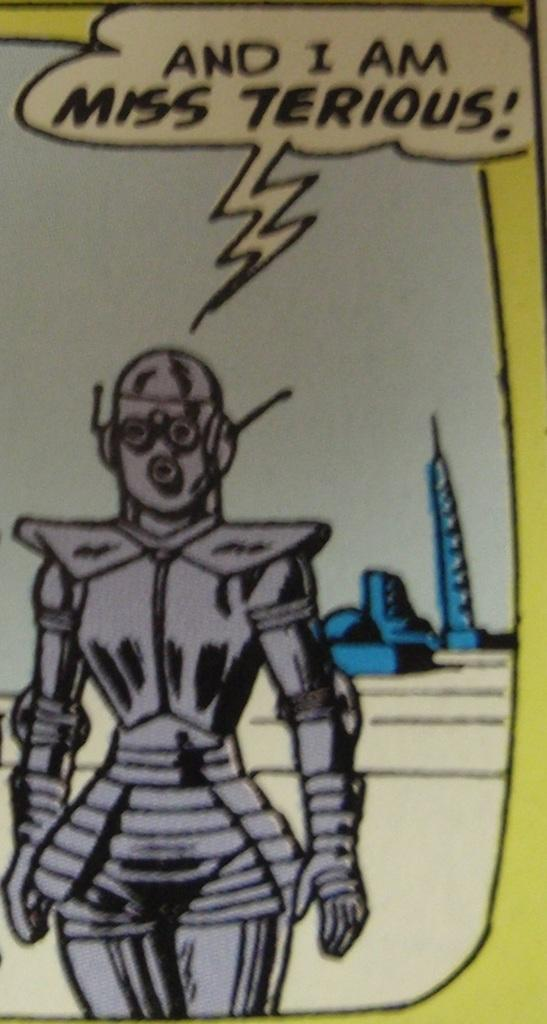What type of picture is shown in the image? The image is an animated picture. What is the main subject of the animated picture? The picture depicts a robot in the shape of a woman. What can be seen in the background of the image? The sky is visible at the top of the image. What type of yarn is the robot using to grip objects in the image? There is no yarn or gripping of objects shown in the image; it depicts an animated robot in the shape of a woman. 